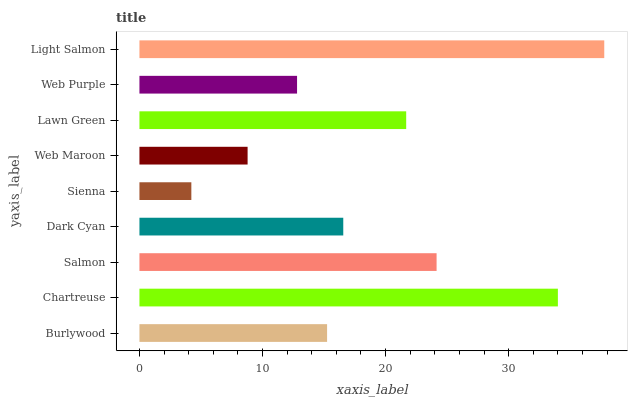Is Sienna the minimum?
Answer yes or no. Yes. Is Light Salmon the maximum?
Answer yes or no. Yes. Is Chartreuse the minimum?
Answer yes or no. No. Is Chartreuse the maximum?
Answer yes or no. No. Is Chartreuse greater than Burlywood?
Answer yes or no. Yes. Is Burlywood less than Chartreuse?
Answer yes or no. Yes. Is Burlywood greater than Chartreuse?
Answer yes or no. No. Is Chartreuse less than Burlywood?
Answer yes or no. No. Is Dark Cyan the high median?
Answer yes or no. Yes. Is Dark Cyan the low median?
Answer yes or no. Yes. Is Web Purple the high median?
Answer yes or no. No. Is Chartreuse the low median?
Answer yes or no. No. 